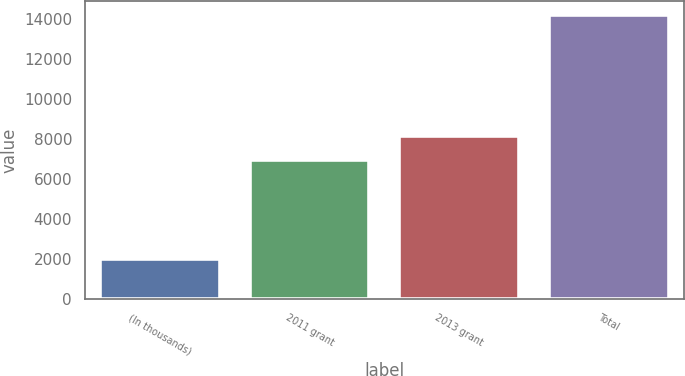Convert chart. <chart><loc_0><loc_0><loc_500><loc_500><bar_chart><fcel>(In thousands)<fcel>2011 grant<fcel>2013 grant<fcel>Total<nl><fcel>2013<fcel>6939<fcel>8154.7<fcel>14170<nl></chart> 